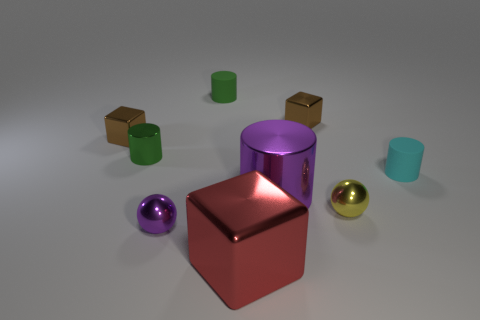What is the shape of the purple thing that is the same size as the green metallic cylinder?
Ensure brevity in your answer.  Sphere. What number of other objects are there of the same color as the large shiny cube?
Offer a terse response. 0. What is the size of the brown object that is left of the ball that is on the left side of the small yellow metallic sphere?
Ensure brevity in your answer.  Small. Is the big thing that is in front of the purple metal cylinder made of the same material as the large purple thing?
Keep it short and to the point. Yes. What is the shape of the brown thing to the right of the tiny green shiny object?
Provide a short and direct response. Cube. How many cylinders have the same size as the cyan object?
Your answer should be compact. 2. How big is the cyan matte cylinder?
Make the answer very short. Small. What number of small yellow metallic balls are to the left of the green shiny cylinder?
Offer a very short reply. 0. The small purple object that is the same material as the large cube is what shape?
Offer a very short reply. Sphere. Are there fewer balls that are behind the green shiny object than green rubber cylinders right of the green rubber thing?
Provide a succinct answer. No. 